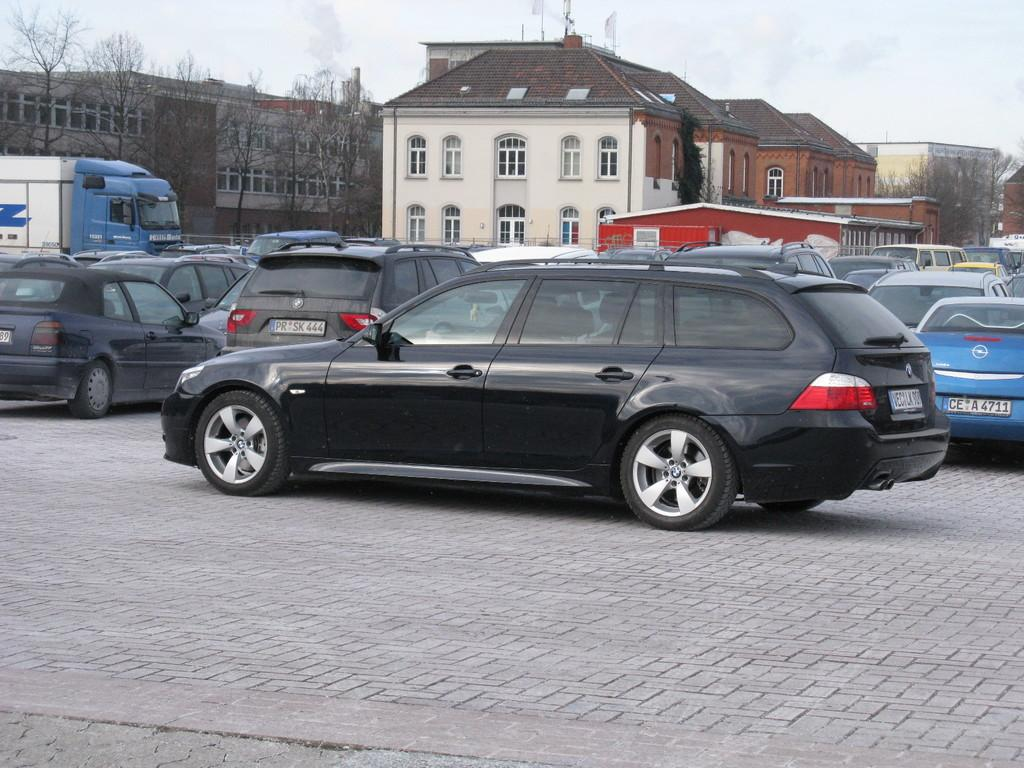What is located in the foreground of the image? There are cars in the foreground of the image. What can be seen in the background of the image? There are houses, trees, and the sky visible in the background of the image. What type of toothpaste is being used by the cars in the image? There is no toothpaste present in the image, as it features cars in the foreground and houses, trees, and the sky in the background. 